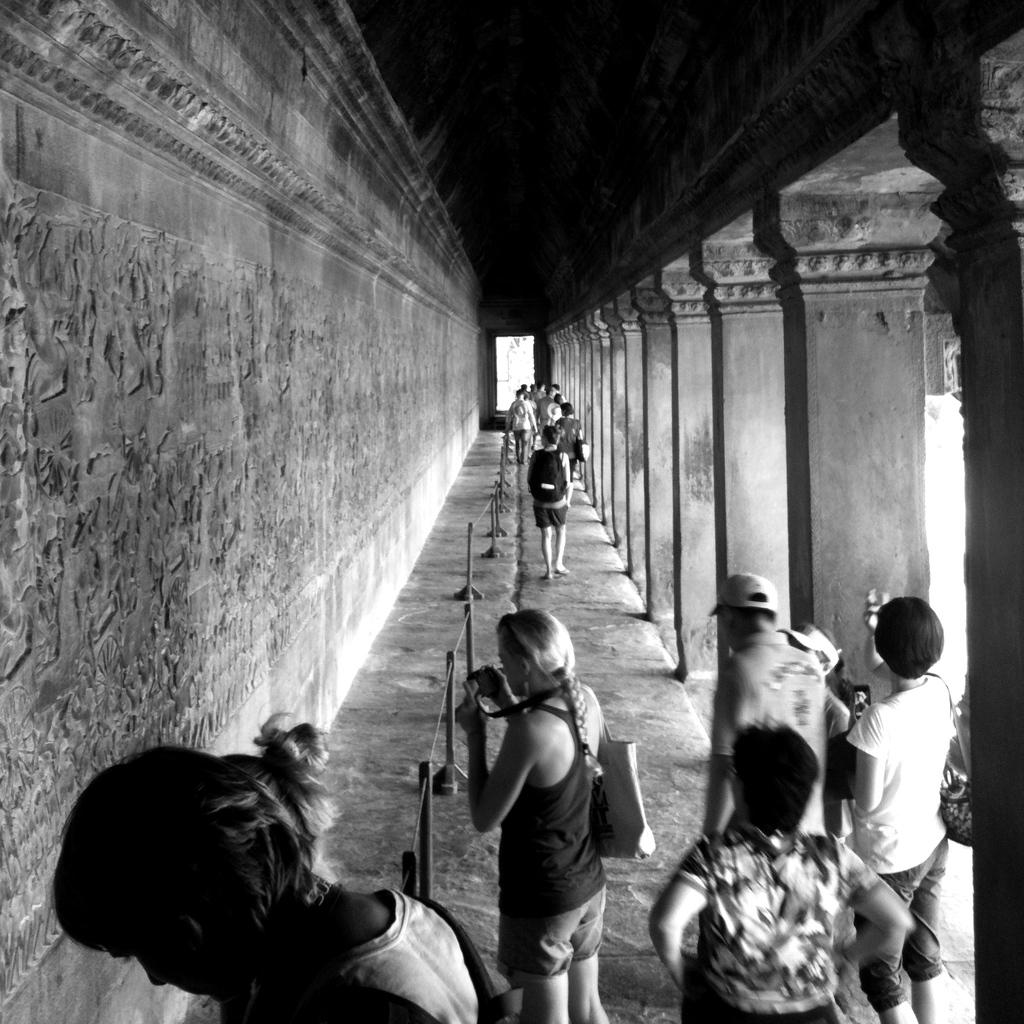What are the people in the image doing? The people in the image are walking on a path. Can you describe what the woman in the image is holding? The woman in the image is holding a camera. What is the color of the wall on the left side of the image? The wall on the left side of the image is gray. What architectural features can be seen on the right side of the image? There are pillars on the right side of the image. What type of quartz can be seen in the woman's hand in the image? There is no quartz present in the image; the woman is holding a camera. How does the woman use the comb in the image? There is no comb present in the image; the woman is holding a camera. 